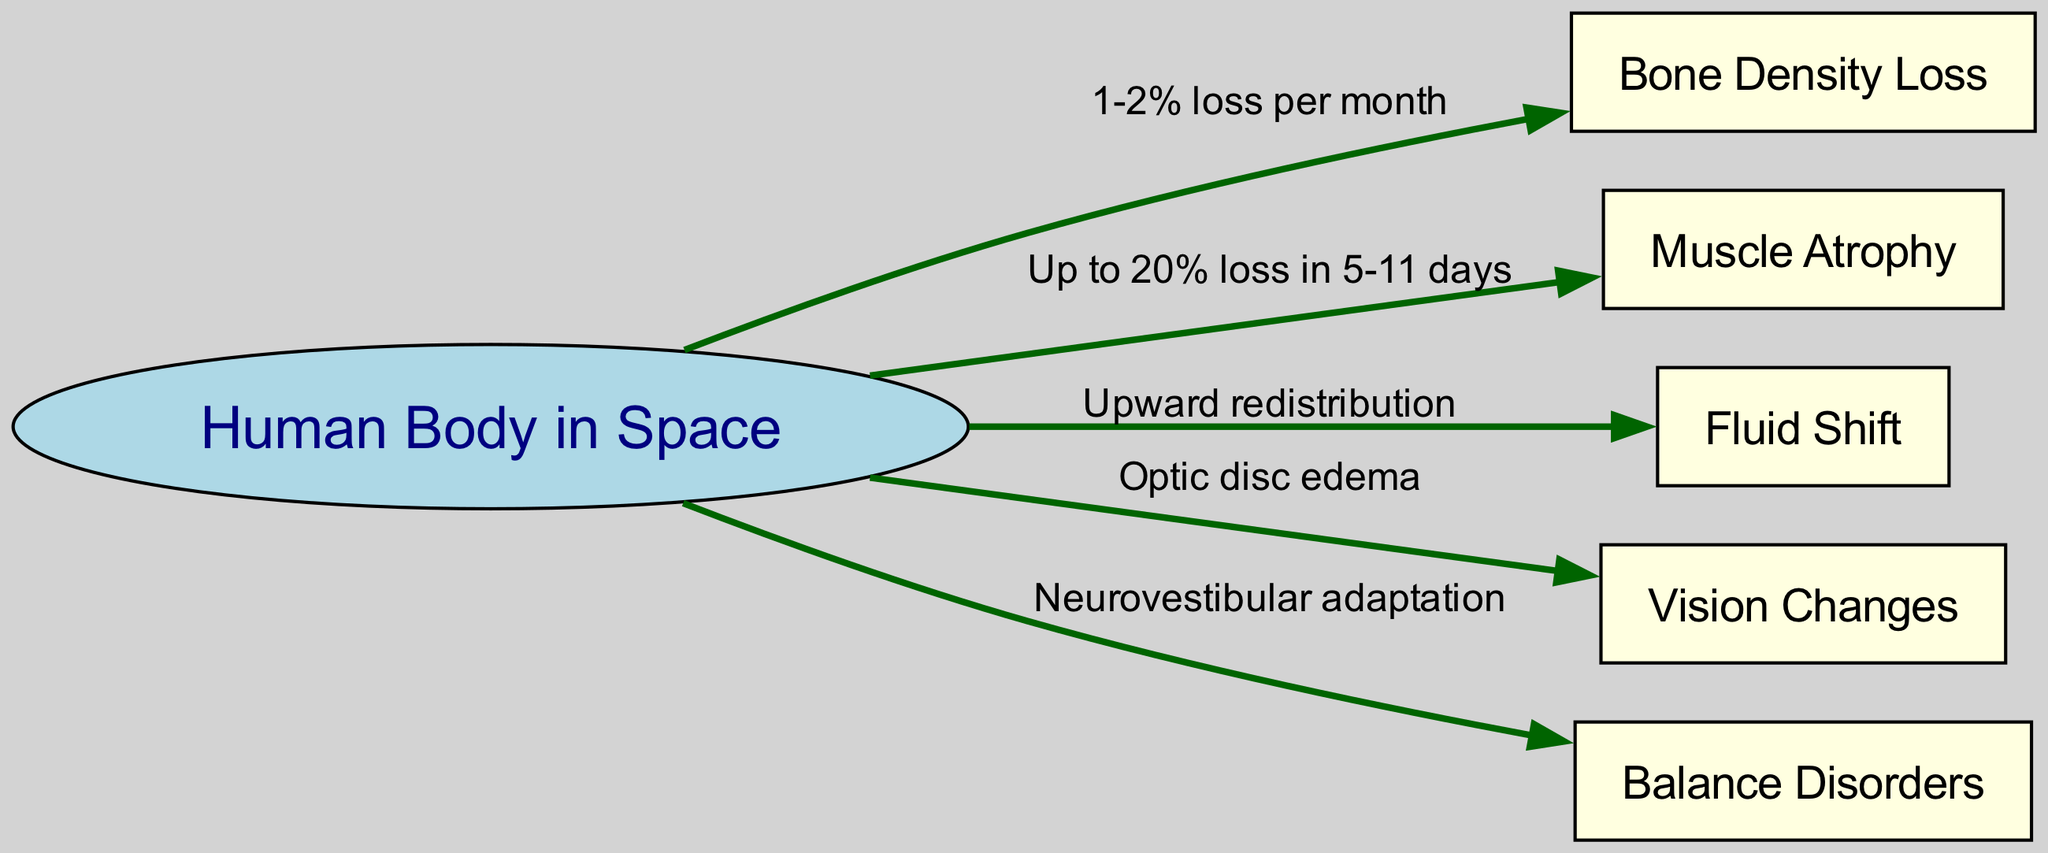What is the label of the first node in the diagram? The first node listed in the diagram is labeled as "Human Body in Space." This is directly taken from the node information provided.
Answer: Human Body in Space How much bone density loss occurs per month in microgravity? The edge connecting the "Human Body in Space" to "Bone Density Loss" specifies that there is a "1-2% loss per month." Thus, this is the direct information stated on the diagram.
Answer: 1-2% loss per month Which physiological effect has an upward redistribution of fluids? The edge from "Human Body in Space" to "Fluid Shift" indicates that the physiological effect related to fluids is "Upward redistribution." This is explicitly detailed in the diagram.
Answer: Upward redistribution How much muscle loss can occur in 5 to 11 days? The diagram states that there can be "Up to 20% loss in 5-11 days" related to muscle atrophy, which is indicated by the connection from "Human Body in Space" to "Muscle Atrophy."
Answer: Up to 20% loss in 5-11 days What physiological issue is associated with optic disc edema? The connection from the "Human Body in Space" to "Vision Changes" highlights the occurrence of "Optic disc edema," making it clear that this vision issue arises in microgravity.
Answer: Optic disc edema What type of adaptation occurs concerning balance in microgravity? The diagram indicates that "Neurovestibular adaptation" occurs as shown by the arrow connecting "Human Body in Space" to "Balance Disorders." This describes the necessary adaptation for balance in space.
Answer: Neurovestibular adaptation How many nodes are displayed in the diagram? The diagram includes a total of six nodes: one for the "Human Body in Space" and five others for the effects of microgravity. By counting each distinct node listed, we reach a total of six.
Answer: 6 What is the relationship between "Human Body in Space" and "Muscle Atrophy"? The edge from "Human Body in Space" to "Muscle Atrophy" shows that the relationship involves a significant loss of muscle mass, stating an "Up to 20% loss in 5-11 days," directly linking the two.
Answer: Up to 20% loss in 5-11 days 